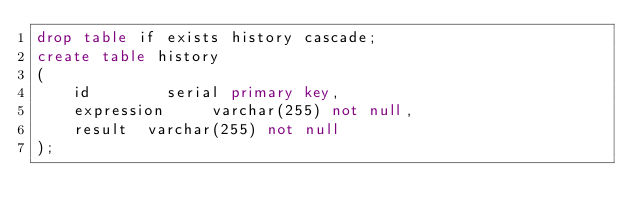Convert code to text. <code><loc_0><loc_0><loc_500><loc_500><_SQL_>drop table if exists history cascade;
create table history
(
    id        serial primary key,
    expression     varchar(255) not null,
    result  varchar(255) not null
);</code> 